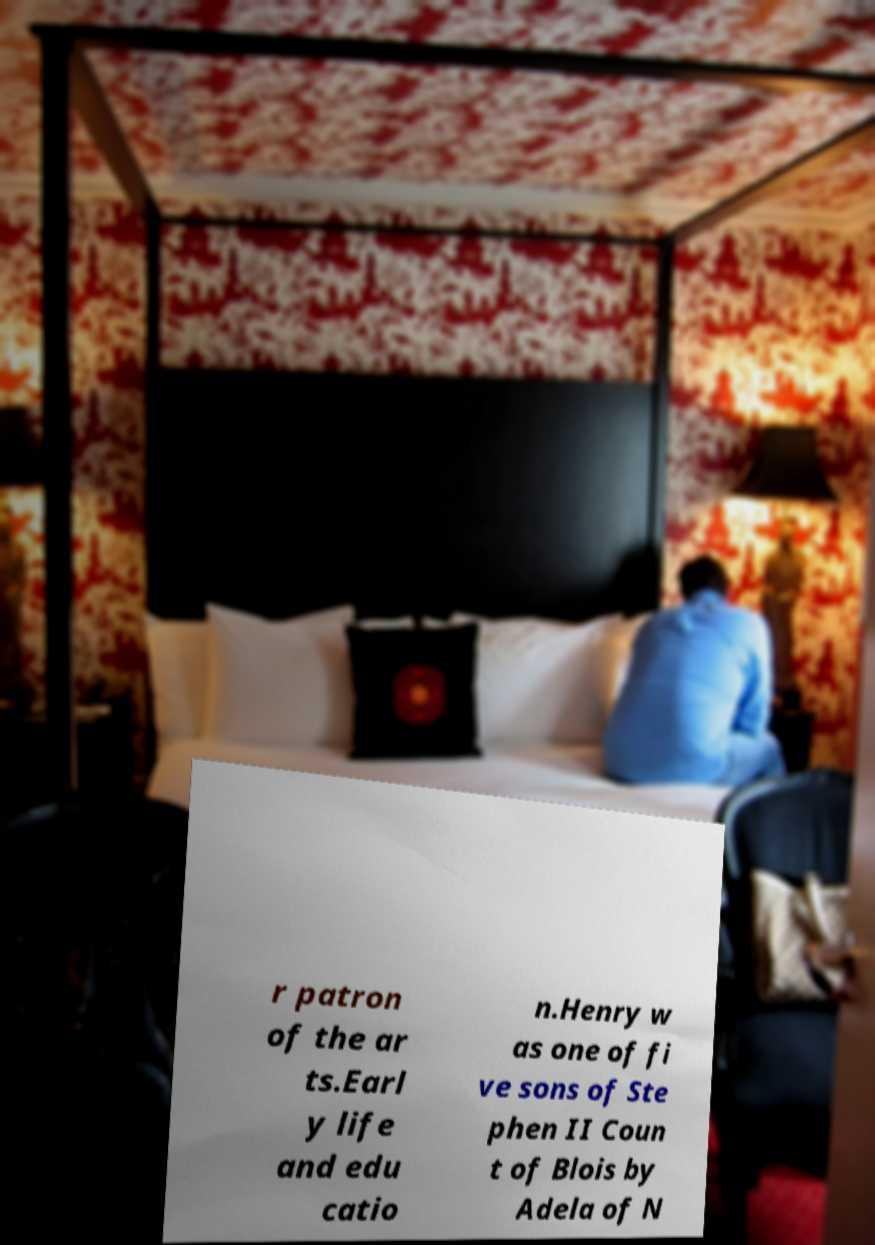Can you accurately transcribe the text from the provided image for me? r patron of the ar ts.Earl y life and edu catio n.Henry w as one of fi ve sons of Ste phen II Coun t of Blois by Adela of N 